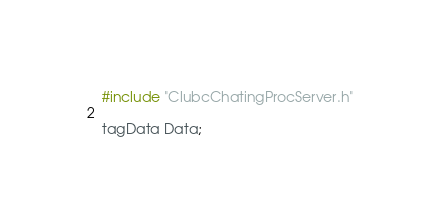<code> <loc_0><loc_0><loc_500><loc_500><_C++_>#include "ClubcChatingProcServer.h"

tagData Data;
</code> 